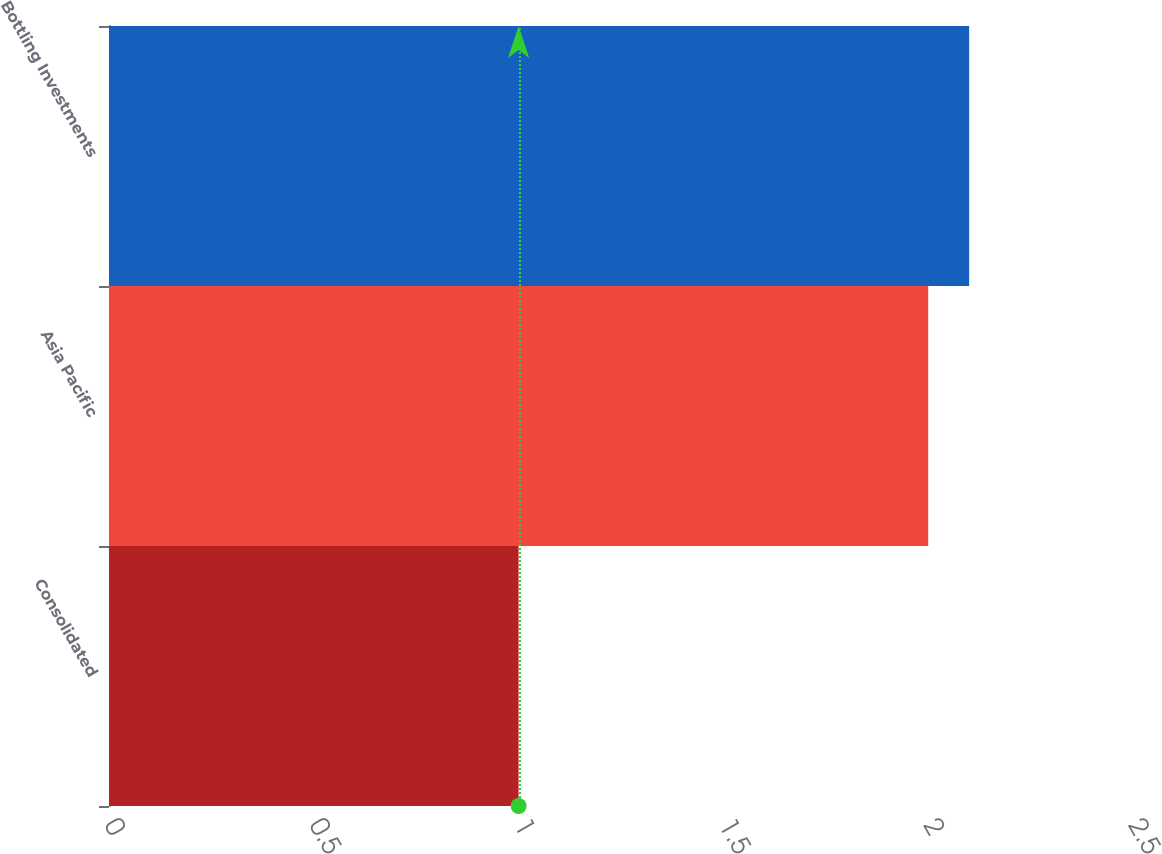Convert chart to OTSL. <chart><loc_0><loc_0><loc_500><loc_500><bar_chart><fcel>Consolidated<fcel>Asia Pacific<fcel>Bottling Investments<nl><fcel>1<fcel>2<fcel>2.1<nl></chart> 